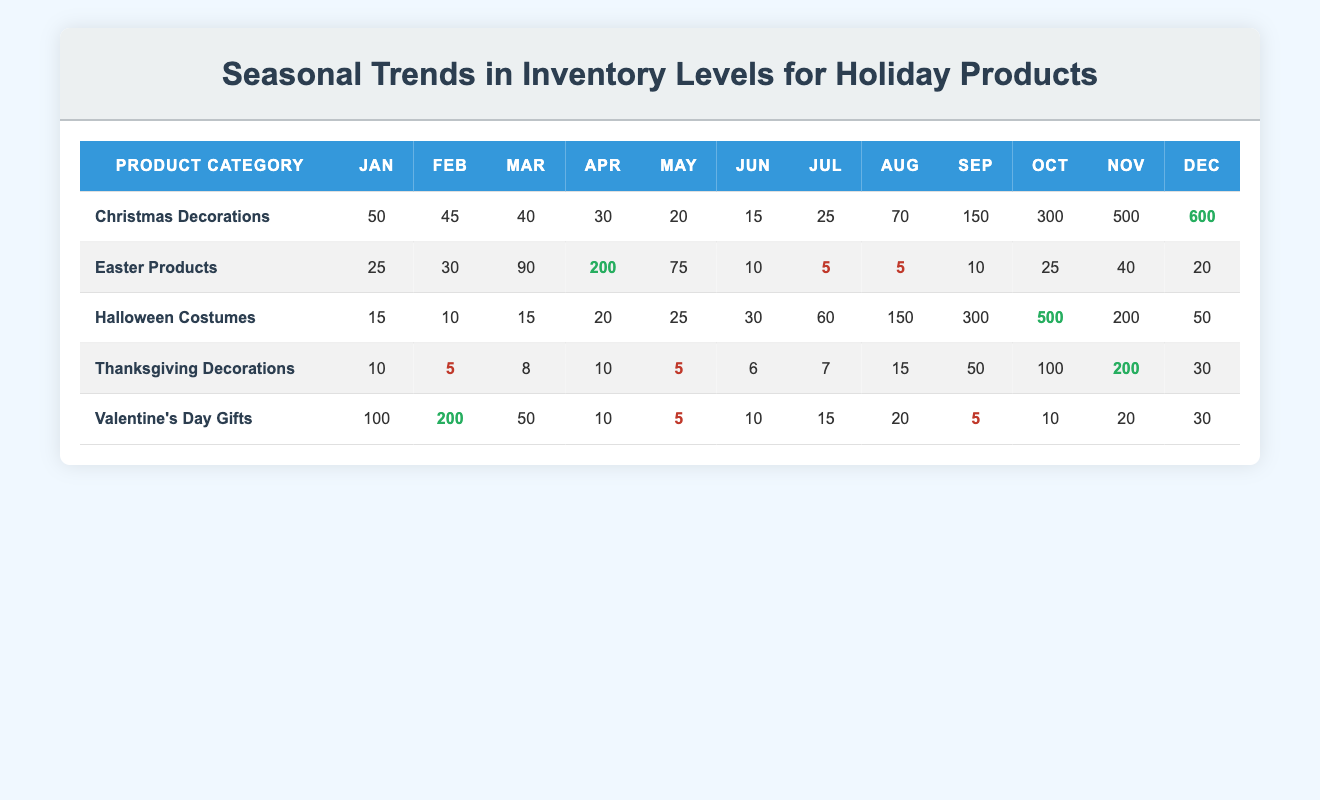What is the highest inventory level for Christmas Decorations? Referring to the "Christmas Decorations" row, the highest inventory level is shown in December, where the value is 600.
Answer: 600 In which month do Halloween Costumes have the lowest inventory? In the "Halloween Costumes" row, the lowest inventory level can be found in January and February with a value of 15 and 10, respectively. Thus, February with 10 is the lowest.
Answer: February What is the average inventory level for Valentine's Day Gifts? To calculate the average, sum the inventory levels for each month: 100 + 200 + 50 + 10 + 5 + 10 + 15 + 20 + 5 + 10 + 20 + 30 =  525. There are 12 months, so the average is 525 / 12 = 43.75.
Answer: 43.75 Is the inventory level for Thanksgiving Decorations ever above 100? Reviewing the "Thanksgiving Decorations" row, the inventory level exceeds 100 only in November, where it reaches 200, confirming that it is yes.
Answer: Yes What is the total inventory level for Easter Products from March to June? For Easter Products, the monthly inventory levels from March to June are: March (90), April (200), May (75), and June (10), so their total is 90 + 200 + 75 + 10 = 375.
Answer: 375 What month has the highest inventory level for Valentine's Day Gifts? Looking at the "Valentine’s Day Gifts" row, the highest inventory level appears in February with a value of 200.
Answer: February How does the inventory for Christmas Decorations in October compare to that in November? The inventory level for Christmas Decorations in October is 300, while the level in November is 500. Therefore, November has a higher inventory level by 200.
Answer: November has a higher level In what month do Thanksgiving Decorations show the highest inventory? By examining the "Thanksgiving Decorations" row, it is clear that the highest inventory level occurs in November, where it reaches 200.
Answer: November Which holiday product category has the highest inventory level in December? The row for "Christmas Decorations" shows an inventory level of 600 in December, which is higher than all other categories listed.
Answer: Christmas Decorations 